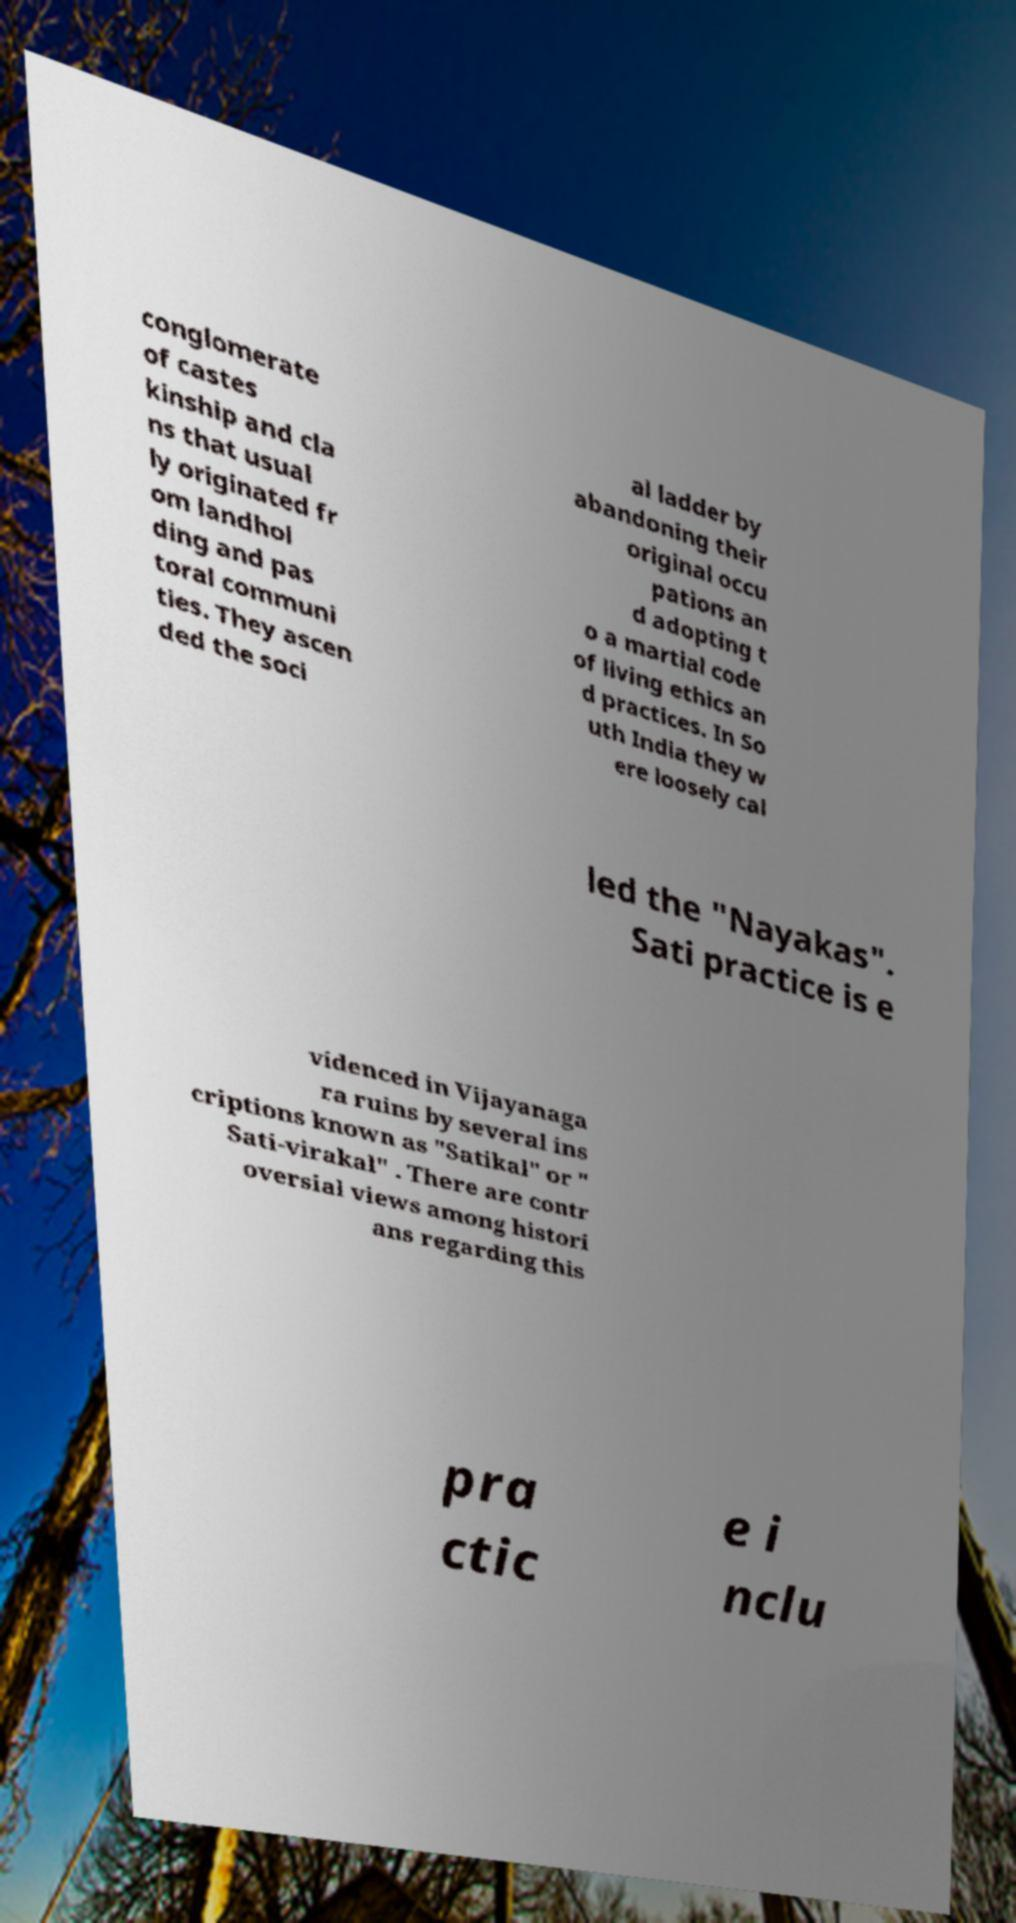Can you read and provide the text displayed in the image?This photo seems to have some interesting text. Can you extract and type it out for me? conglomerate of castes kinship and cla ns that usual ly originated fr om landhol ding and pas toral communi ties. They ascen ded the soci al ladder by abandoning their original occu pations an d adopting t o a martial code of living ethics an d practices. In So uth India they w ere loosely cal led the "Nayakas". Sati practice is e videnced in Vijayanaga ra ruins by several ins criptions known as "Satikal" or " Sati-virakal" . There are contr oversial views among histori ans regarding this pra ctic e i nclu 